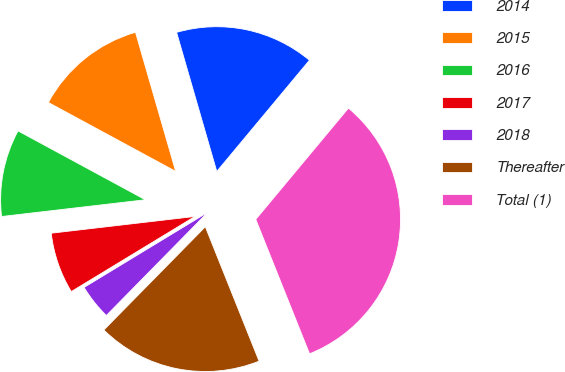Convert chart to OTSL. <chart><loc_0><loc_0><loc_500><loc_500><pie_chart><fcel>2014<fcel>2015<fcel>2016<fcel>2017<fcel>2018<fcel>Thereafter<fcel>Total (1)<nl><fcel>15.53%<fcel>12.63%<fcel>9.74%<fcel>6.84%<fcel>3.95%<fcel>18.42%<fcel>32.89%<nl></chart> 